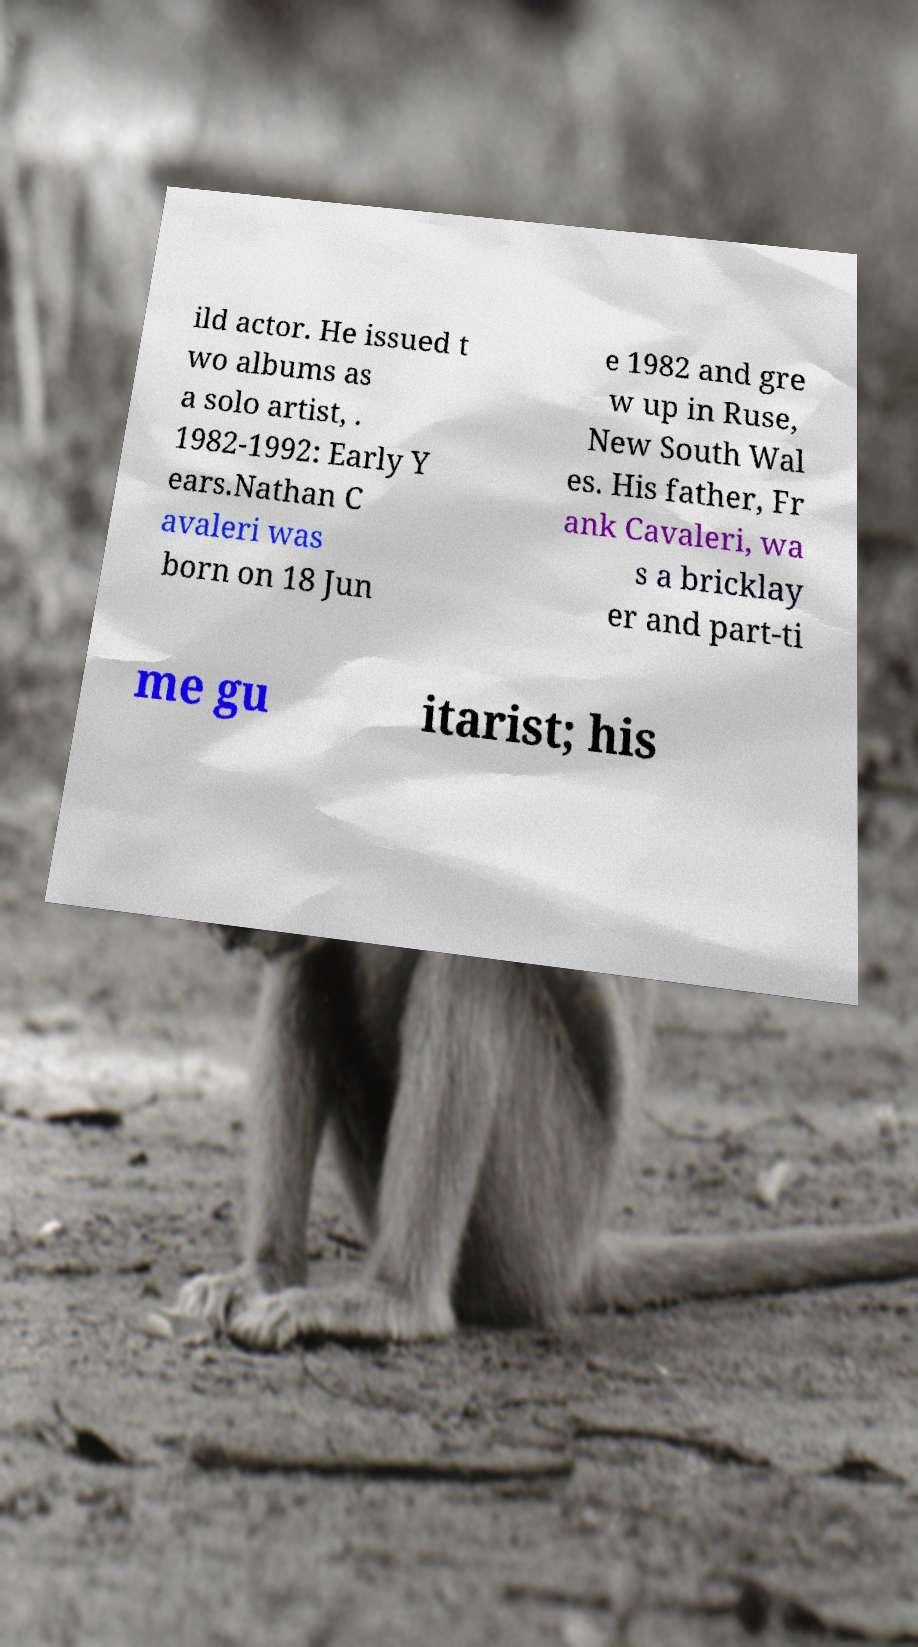There's text embedded in this image that I need extracted. Can you transcribe it verbatim? ild actor. He issued t wo albums as a solo artist, . 1982-1992: Early Y ears.Nathan C avaleri was born on 18 Jun e 1982 and gre w up in Ruse, New South Wal es. His father, Fr ank Cavaleri, wa s a bricklay er and part-ti me gu itarist; his 